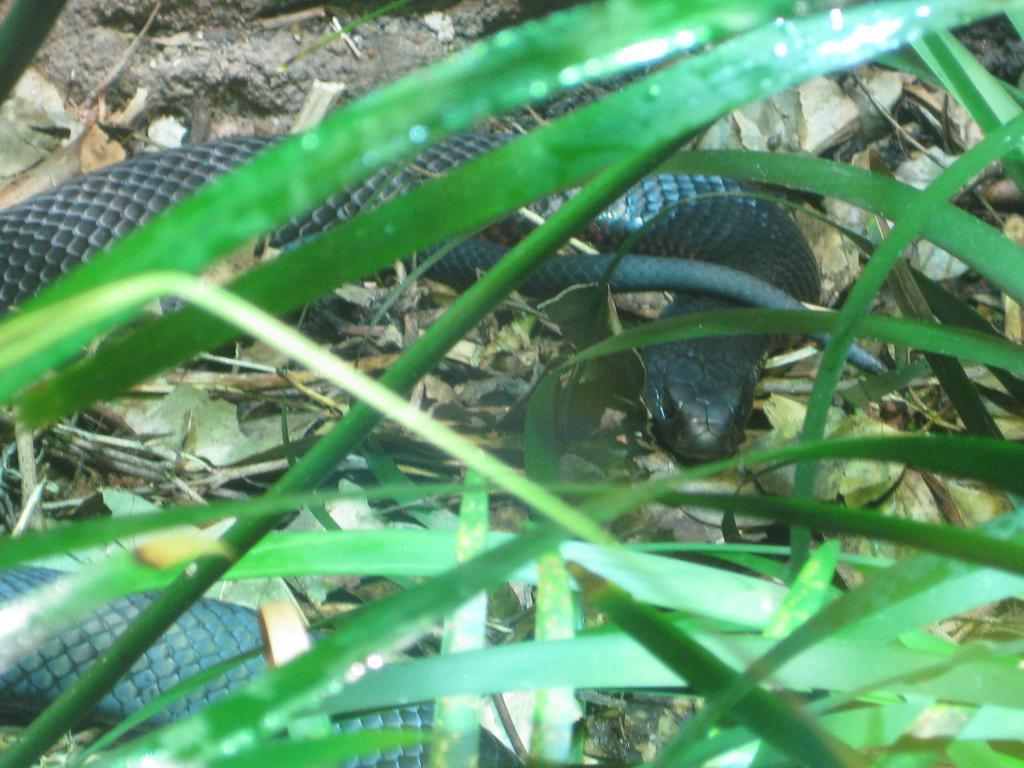What animal is present in the image? There is a snake in the image. What is the color of the snake? The snake is black in color. Where is the snake located in the image? The snake is on the ground. What type of vegetation can be seen in the image? There are green leaves in the image. What is the snake arguing about with the squirrel in the image? There is no squirrel present in the image, and therefore no argument can be observed. 